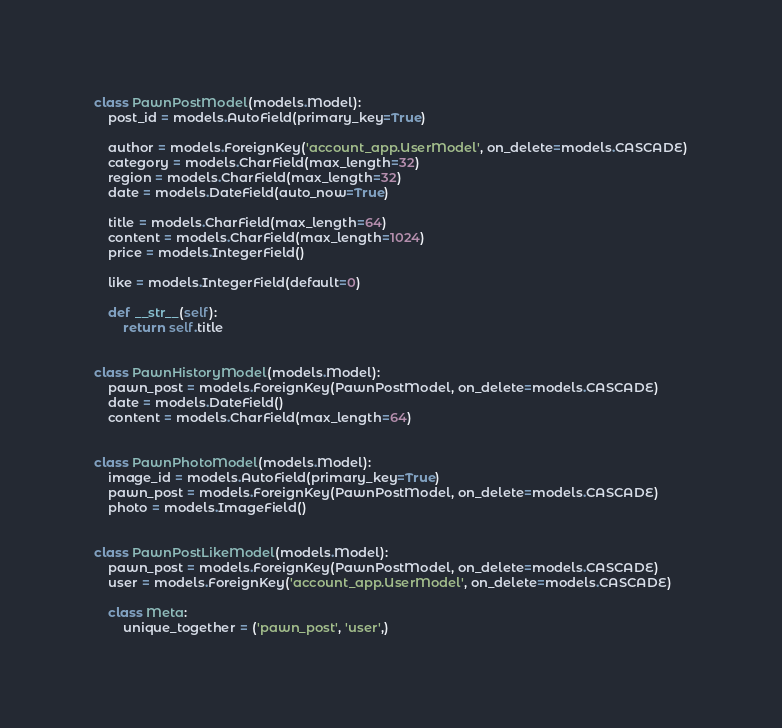<code> <loc_0><loc_0><loc_500><loc_500><_Python_>

class PawnPostModel(models.Model):
    post_id = models.AutoField(primary_key=True)

    author = models.ForeignKey('account_app.UserModel', on_delete=models.CASCADE)
    category = models.CharField(max_length=32)
    region = models.CharField(max_length=32)
    date = models.DateField(auto_now=True)

    title = models.CharField(max_length=64)
    content = models.CharField(max_length=1024)
    price = models.IntegerField()

    like = models.IntegerField(default=0)

    def __str__(self):
        return self.title


class PawnHistoryModel(models.Model):
    pawn_post = models.ForeignKey(PawnPostModel, on_delete=models.CASCADE)
    date = models.DateField()
    content = models.CharField(max_length=64)


class PawnPhotoModel(models.Model):
    image_id = models.AutoField(primary_key=True)
    pawn_post = models.ForeignKey(PawnPostModel, on_delete=models.CASCADE)
    photo = models.ImageField()


class PawnPostLikeModel(models.Model):
    pawn_post = models.ForeignKey(PawnPostModel, on_delete=models.CASCADE)
    user = models.ForeignKey('account_app.UserModel', on_delete=models.CASCADE)

    class Meta:
        unique_together = ('pawn_post', 'user',)
</code> 